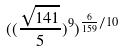Convert formula to latex. <formula><loc_0><loc_0><loc_500><loc_500>( ( \frac { \sqrt { 1 4 1 } } { 5 } ) ^ { 9 } ) ^ { \frac { 6 } { 1 5 9 } / 1 0 }</formula> 